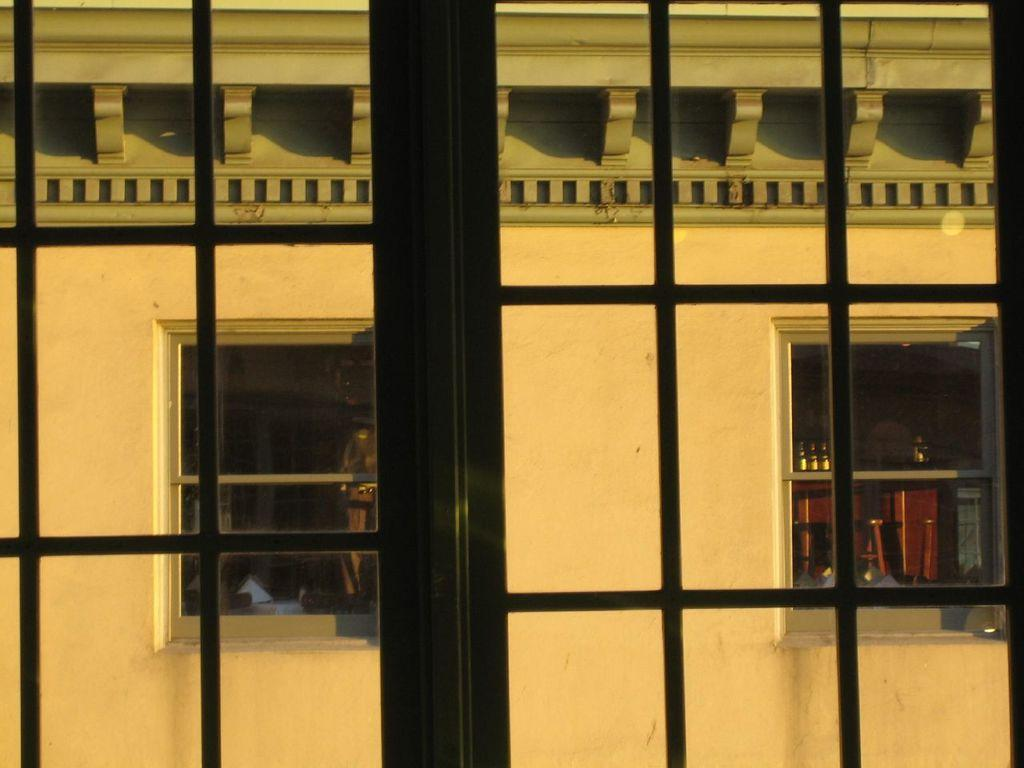What is located in the front of the image? There are iron bars in the front of the image. What can be seen in the background of the image? There is a wall visible in the background of the image, along with two windows. What is visible through the windows? Bottles, a table, and other unspecified objects are visible through the windows. Where is the sink located in the image? There is no sink present in the image. What type of card can be seen on the table through the windows? There is no card visible through the windows in the image. 